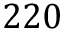<formula> <loc_0><loc_0><loc_500><loc_500>2 2 0</formula> 